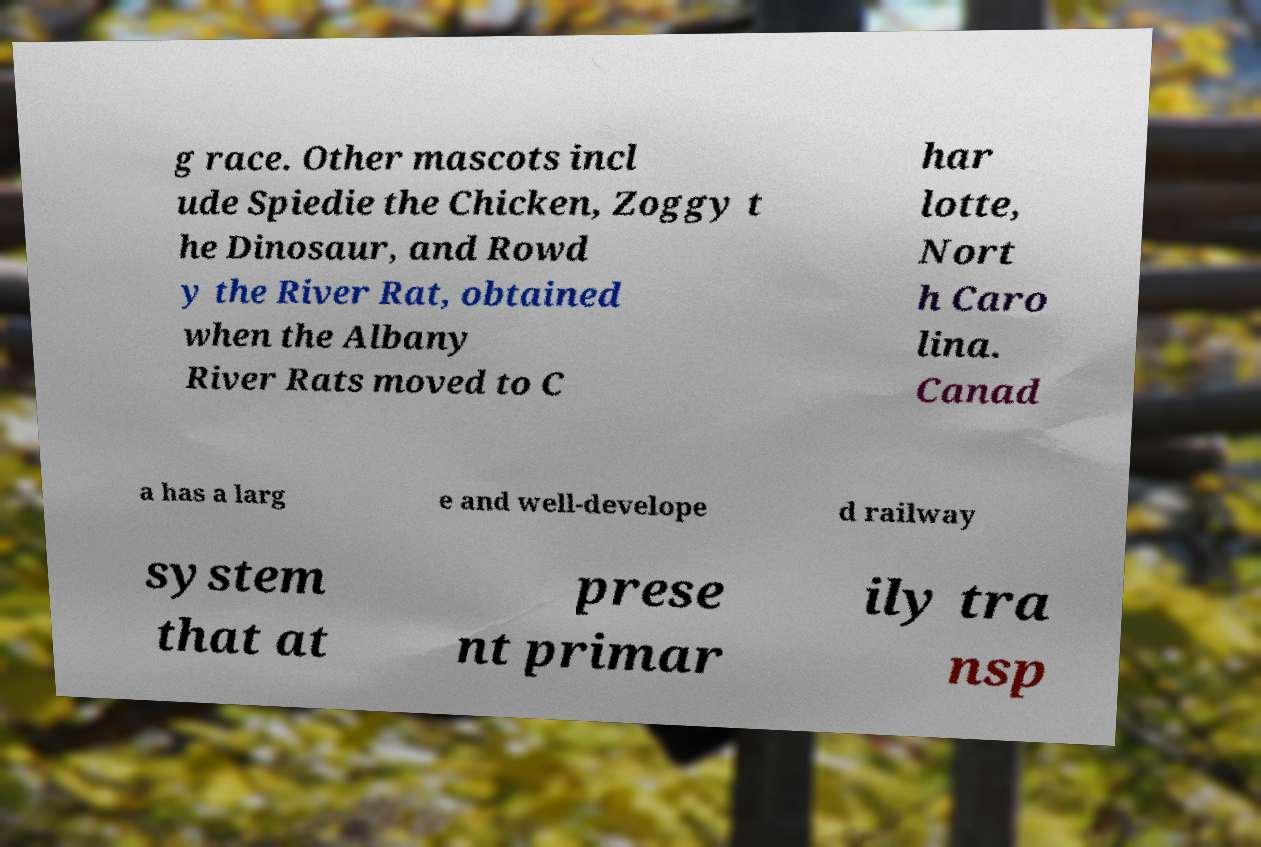Can you accurately transcribe the text from the provided image for me? g race. Other mascots incl ude Spiedie the Chicken, Zoggy t he Dinosaur, and Rowd y the River Rat, obtained when the Albany River Rats moved to C har lotte, Nort h Caro lina. Canad a has a larg e and well-develope d railway system that at prese nt primar ily tra nsp 